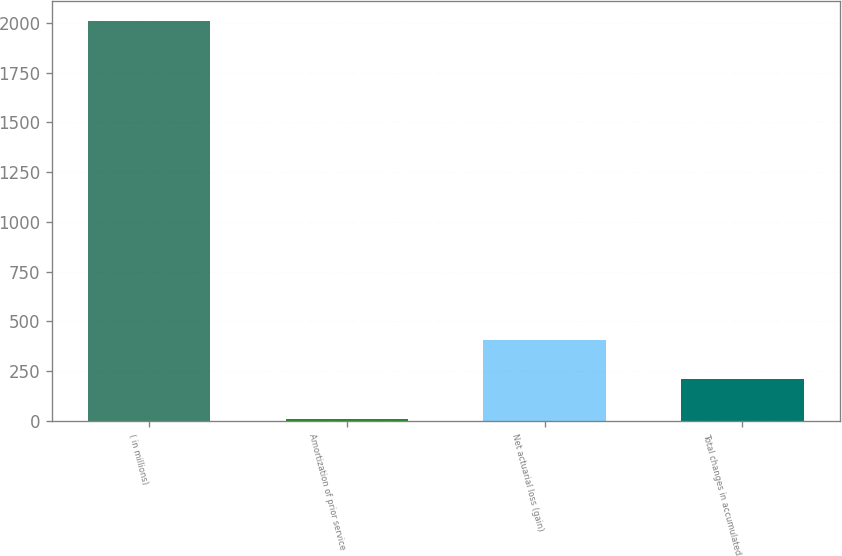Convert chart to OTSL. <chart><loc_0><loc_0><loc_500><loc_500><bar_chart><fcel>( in millions)<fcel>Amortization of prior service<fcel>Net actuarial loss (gain)<fcel>Total changes in accumulated<nl><fcel>2012<fcel>7<fcel>408<fcel>207.5<nl></chart> 